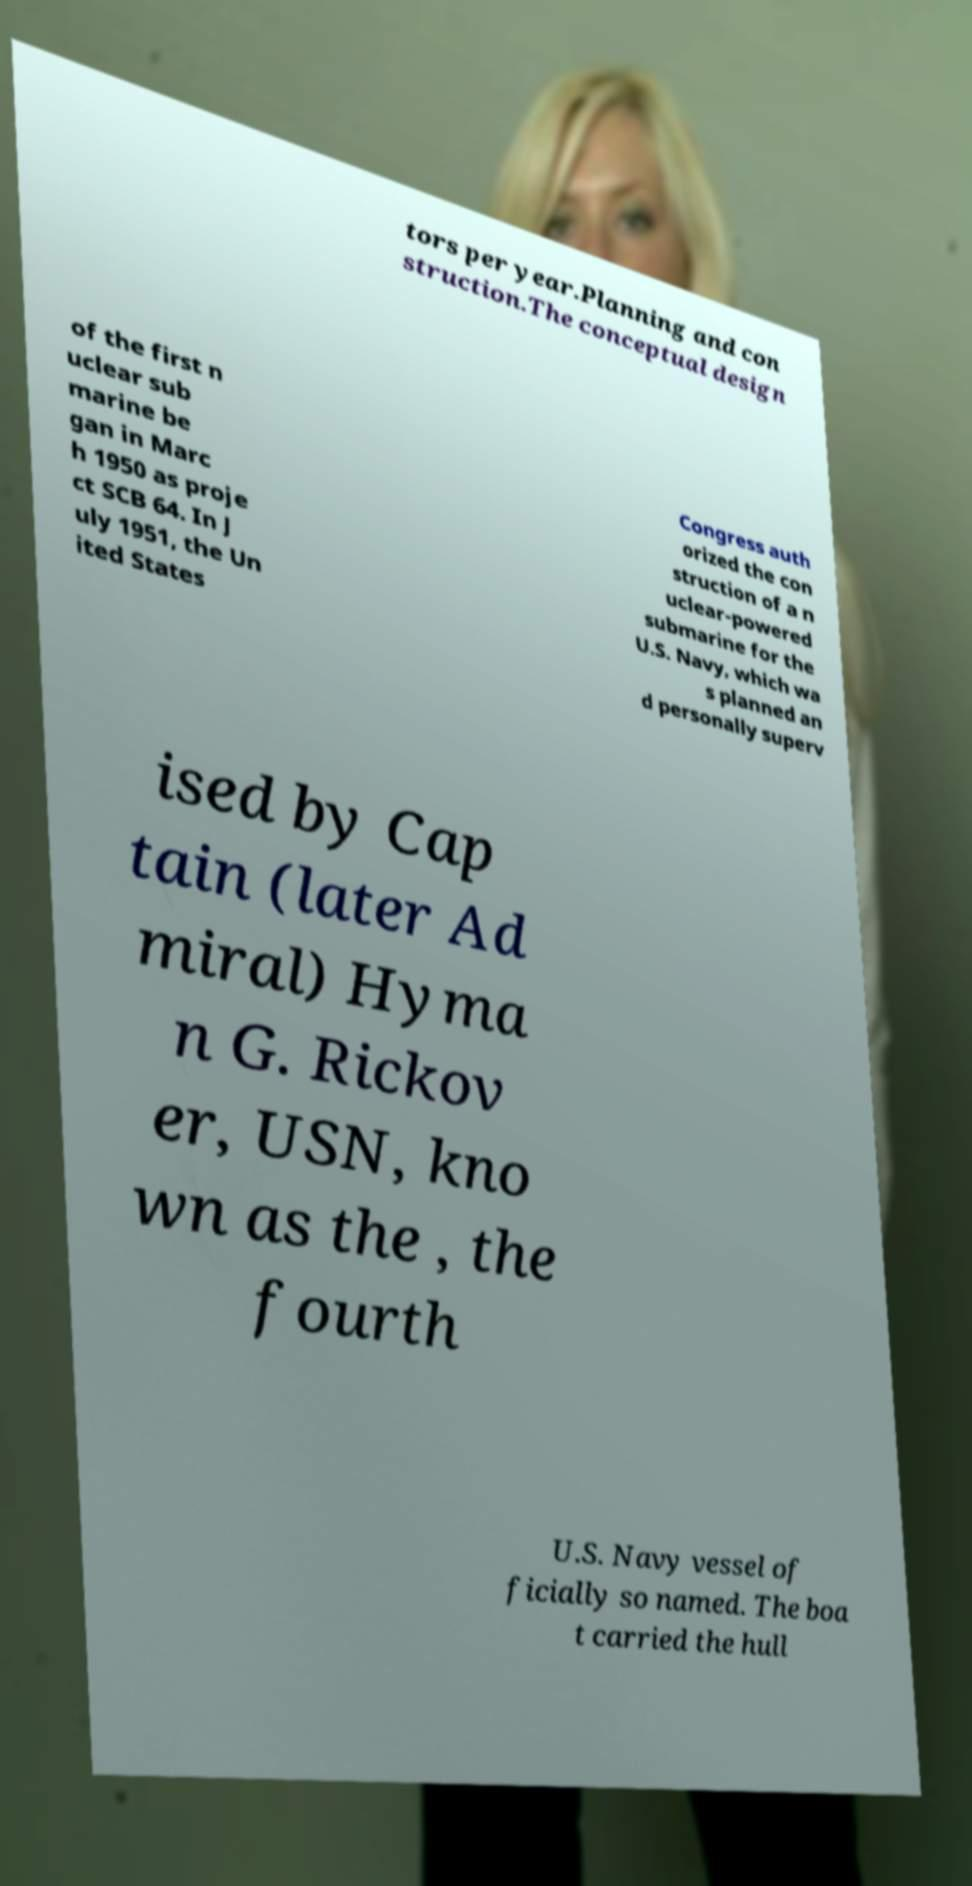What messages or text are displayed in this image? I need them in a readable, typed format. tors per year.Planning and con struction.The conceptual design of the first n uclear sub marine be gan in Marc h 1950 as proje ct SCB 64. In J uly 1951, the Un ited States Congress auth orized the con struction of a n uclear-powered submarine for the U.S. Navy, which wa s planned an d personally superv ised by Cap tain (later Ad miral) Hyma n G. Rickov er, USN, kno wn as the , the fourth U.S. Navy vessel of ficially so named. The boa t carried the hull 